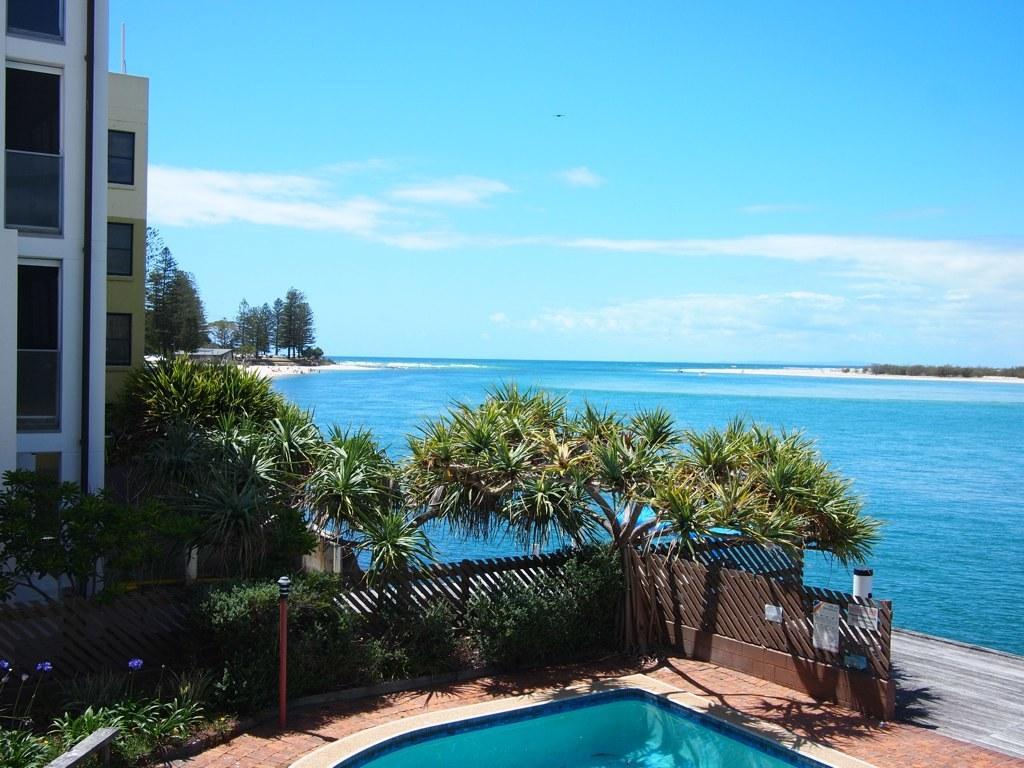Describe this image in one or two sentences. In this image in the front there are plants and in the background there is water, there are trees. On the left side there are buildings and the sky is cloudy. In the front there is a wooden fence and there is a pole. 